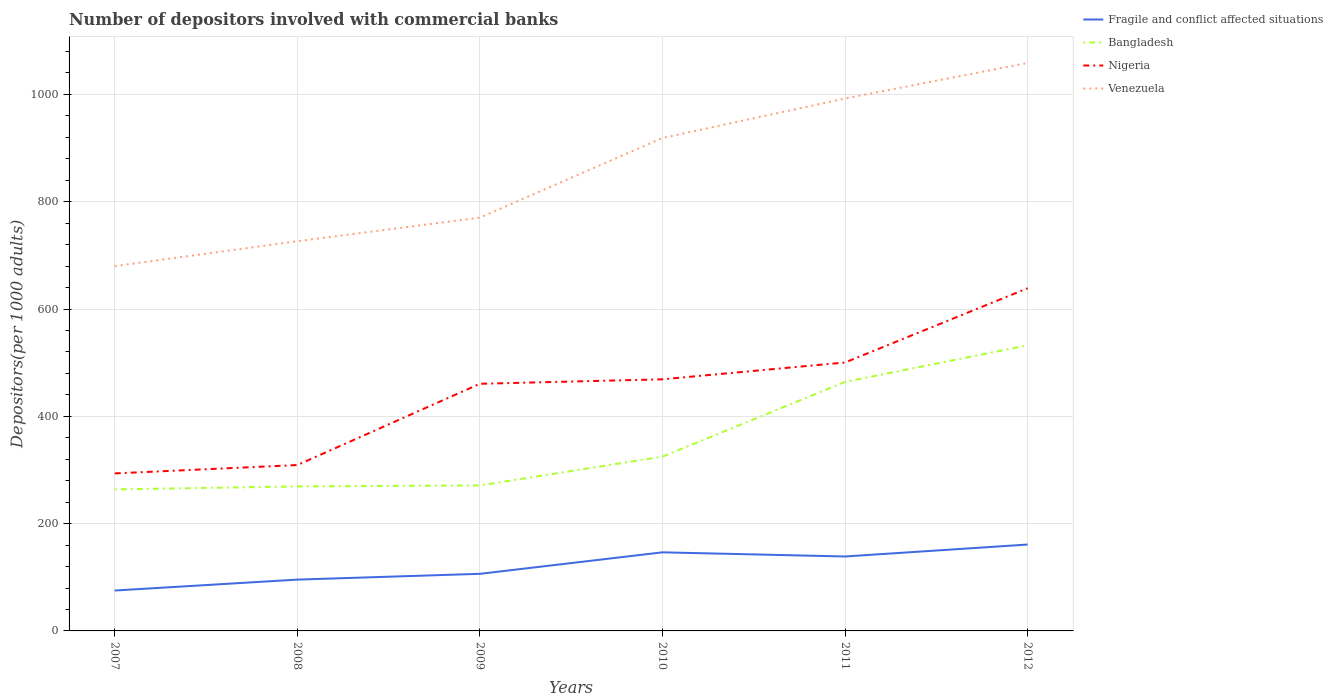Is the number of lines equal to the number of legend labels?
Offer a terse response. Yes. Across all years, what is the maximum number of depositors involved with commercial banks in Bangladesh?
Make the answer very short. 263.8. In which year was the number of depositors involved with commercial banks in Venezuela maximum?
Offer a very short reply. 2007. What is the total number of depositors involved with commercial banks in Bangladesh in the graph?
Offer a very short reply. -1.91. What is the difference between the highest and the second highest number of depositors involved with commercial banks in Bangladesh?
Provide a short and direct response. 268.6. What is the difference between the highest and the lowest number of depositors involved with commercial banks in Venezuela?
Provide a short and direct response. 3. How many lines are there?
Keep it short and to the point. 4. How many years are there in the graph?
Your answer should be compact. 6. Are the values on the major ticks of Y-axis written in scientific E-notation?
Offer a terse response. No. Does the graph contain any zero values?
Your response must be concise. No. Where does the legend appear in the graph?
Your response must be concise. Top right. How many legend labels are there?
Your answer should be very brief. 4. How are the legend labels stacked?
Your response must be concise. Vertical. What is the title of the graph?
Provide a short and direct response. Number of depositors involved with commercial banks. What is the label or title of the Y-axis?
Offer a terse response. Depositors(per 1000 adults). What is the Depositors(per 1000 adults) of Fragile and conflict affected situations in 2007?
Your answer should be very brief. 75.3. What is the Depositors(per 1000 adults) in Bangladesh in 2007?
Offer a terse response. 263.8. What is the Depositors(per 1000 adults) in Nigeria in 2007?
Ensure brevity in your answer.  293.59. What is the Depositors(per 1000 adults) of Venezuela in 2007?
Provide a succinct answer. 679.99. What is the Depositors(per 1000 adults) in Fragile and conflict affected situations in 2008?
Ensure brevity in your answer.  95.65. What is the Depositors(per 1000 adults) of Bangladesh in 2008?
Provide a short and direct response. 269.32. What is the Depositors(per 1000 adults) of Nigeria in 2008?
Offer a very short reply. 309.17. What is the Depositors(per 1000 adults) in Venezuela in 2008?
Give a very brief answer. 726.32. What is the Depositors(per 1000 adults) of Fragile and conflict affected situations in 2009?
Your answer should be very brief. 106.41. What is the Depositors(per 1000 adults) in Bangladesh in 2009?
Offer a very short reply. 271.23. What is the Depositors(per 1000 adults) of Nigeria in 2009?
Provide a succinct answer. 460.66. What is the Depositors(per 1000 adults) in Venezuela in 2009?
Provide a succinct answer. 770.33. What is the Depositors(per 1000 adults) in Fragile and conflict affected situations in 2010?
Keep it short and to the point. 146.5. What is the Depositors(per 1000 adults) of Bangladesh in 2010?
Ensure brevity in your answer.  324.78. What is the Depositors(per 1000 adults) in Nigeria in 2010?
Your answer should be compact. 468.98. What is the Depositors(per 1000 adults) of Venezuela in 2010?
Give a very brief answer. 918.79. What is the Depositors(per 1000 adults) in Fragile and conflict affected situations in 2011?
Keep it short and to the point. 138.74. What is the Depositors(per 1000 adults) in Bangladesh in 2011?
Keep it short and to the point. 464.13. What is the Depositors(per 1000 adults) in Nigeria in 2011?
Make the answer very short. 500.36. What is the Depositors(per 1000 adults) in Venezuela in 2011?
Offer a terse response. 992.39. What is the Depositors(per 1000 adults) of Fragile and conflict affected situations in 2012?
Ensure brevity in your answer.  161.02. What is the Depositors(per 1000 adults) in Bangladesh in 2012?
Provide a succinct answer. 532.4. What is the Depositors(per 1000 adults) in Nigeria in 2012?
Your answer should be very brief. 638.71. What is the Depositors(per 1000 adults) of Venezuela in 2012?
Your response must be concise. 1058.65. Across all years, what is the maximum Depositors(per 1000 adults) in Fragile and conflict affected situations?
Offer a terse response. 161.02. Across all years, what is the maximum Depositors(per 1000 adults) in Bangladesh?
Provide a short and direct response. 532.4. Across all years, what is the maximum Depositors(per 1000 adults) of Nigeria?
Your response must be concise. 638.71. Across all years, what is the maximum Depositors(per 1000 adults) in Venezuela?
Make the answer very short. 1058.65. Across all years, what is the minimum Depositors(per 1000 adults) in Fragile and conflict affected situations?
Offer a terse response. 75.3. Across all years, what is the minimum Depositors(per 1000 adults) in Bangladesh?
Offer a terse response. 263.8. Across all years, what is the minimum Depositors(per 1000 adults) of Nigeria?
Offer a very short reply. 293.59. Across all years, what is the minimum Depositors(per 1000 adults) in Venezuela?
Offer a terse response. 679.99. What is the total Depositors(per 1000 adults) in Fragile and conflict affected situations in the graph?
Give a very brief answer. 723.62. What is the total Depositors(per 1000 adults) in Bangladesh in the graph?
Provide a succinct answer. 2125.65. What is the total Depositors(per 1000 adults) of Nigeria in the graph?
Make the answer very short. 2671.47. What is the total Depositors(per 1000 adults) in Venezuela in the graph?
Your answer should be very brief. 5146.47. What is the difference between the Depositors(per 1000 adults) of Fragile and conflict affected situations in 2007 and that in 2008?
Make the answer very short. -20.35. What is the difference between the Depositors(per 1000 adults) in Bangladesh in 2007 and that in 2008?
Offer a terse response. -5.52. What is the difference between the Depositors(per 1000 adults) in Nigeria in 2007 and that in 2008?
Provide a short and direct response. -15.58. What is the difference between the Depositors(per 1000 adults) in Venezuela in 2007 and that in 2008?
Provide a succinct answer. -46.33. What is the difference between the Depositors(per 1000 adults) in Fragile and conflict affected situations in 2007 and that in 2009?
Offer a very short reply. -31.11. What is the difference between the Depositors(per 1000 adults) in Bangladesh in 2007 and that in 2009?
Offer a terse response. -7.43. What is the difference between the Depositors(per 1000 adults) in Nigeria in 2007 and that in 2009?
Provide a short and direct response. -167.06. What is the difference between the Depositors(per 1000 adults) of Venezuela in 2007 and that in 2009?
Provide a succinct answer. -90.34. What is the difference between the Depositors(per 1000 adults) of Fragile and conflict affected situations in 2007 and that in 2010?
Your answer should be very brief. -71.2. What is the difference between the Depositors(per 1000 adults) in Bangladesh in 2007 and that in 2010?
Keep it short and to the point. -60.98. What is the difference between the Depositors(per 1000 adults) of Nigeria in 2007 and that in 2010?
Your answer should be very brief. -175.39. What is the difference between the Depositors(per 1000 adults) of Venezuela in 2007 and that in 2010?
Your answer should be very brief. -238.8. What is the difference between the Depositors(per 1000 adults) in Fragile and conflict affected situations in 2007 and that in 2011?
Offer a very short reply. -63.44. What is the difference between the Depositors(per 1000 adults) of Bangladesh in 2007 and that in 2011?
Provide a short and direct response. -200.33. What is the difference between the Depositors(per 1000 adults) in Nigeria in 2007 and that in 2011?
Give a very brief answer. -206.77. What is the difference between the Depositors(per 1000 adults) in Venezuela in 2007 and that in 2011?
Provide a succinct answer. -312.4. What is the difference between the Depositors(per 1000 adults) of Fragile and conflict affected situations in 2007 and that in 2012?
Give a very brief answer. -85.72. What is the difference between the Depositors(per 1000 adults) in Bangladesh in 2007 and that in 2012?
Your answer should be very brief. -268.6. What is the difference between the Depositors(per 1000 adults) in Nigeria in 2007 and that in 2012?
Your answer should be very brief. -345.12. What is the difference between the Depositors(per 1000 adults) of Venezuela in 2007 and that in 2012?
Your answer should be compact. -378.66. What is the difference between the Depositors(per 1000 adults) in Fragile and conflict affected situations in 2008 and that in 2009?
Provide a succinct answer. -10.75. What is the difference between the Depositors(per 1000 adults) in Bangladesh in 2008 and that in 2009?
Your answer should be compact. -1.91. What is the difference between the Depositors(per 1000 adults) in Nigeria in 2008 and that in 2009?
Make the answer very short. -151.48. What is the difference between the Depositors(per 1000 adults) of Venezuela in 2008 and that in 2009?
Keep it short and to the point. -44.02. What is the difference between the Depositors(per 1000 adults) in Fragile and conflict affected situations in 2008 and that in 2010?
Give a very brief answer. -50.84. What is the difference between the Depositors(per 1000 adults) in Bangladesh in 2008 and that in 2010?
Provide a succinct answer. -55.46. What is the difference between the Depositors(per 1000 adults) in Nigeria in 2008 and that in 2010?
Offer a terse response. -159.8. What is the difference between the Depositors(per 1000 adults) in Venezuela in 2008 and that in 2010?
Provide a short and direct response. -192.47. What is the difference between the Depositors(per 1000 adults) of Fragile and conflict affected situations in 2008 and that in 2011?
Keep it short and to the point. -43.09. What is the difference between the Depositors(per 1000 adults) of Bangladesh in 2008 and that in 2011?
Your response must be concise. -194.81. What is the difference between the Depositors(per 1000 adults) of Nigeria in 2008 and that in 2011?
Ensure brevity in your answer.  -191.18. What is the difference between the Depositors(per 1000 adults) of Venezuela in 2008 and that in 2011?
Give a very brief answer. -266.07. What is the difference between the Depositors(per 1000 adults) in Fragile and conflict affected situations in 2008 and that in 2012?
Provide a short and direct response. -65.37. What is the difference between the Depositors(per 1000 adults) of Bangladesh in 2008 and that in 2012?
Ensure brevity in your answer.  -263.08. What is the difference between the Depositors(per 1000 adults) of Nigeria in 2008 and that in 2012?
Your response must be concise. -329.54. What is the difference between the Depositors(per 1000 adults) of Venezuela in 2008 and that in 2012?
Offer a terse response. -332.33. What is the difference between the Depositors(per 1000 adults) of Fragile and conflict affected situations in 2009 and that in 2010?
Your response must be concise. -40.09. What is the difference between the Depositors(per 1000 adults) of Bangladesh in 2009 and that in 2010?
Your answer should be compact. -53.55. What is the difference between the Depositors(per 1000 adults) of Nigeria in 2009 and that in 2010?
Make the answer very short. -8.32. What is the difference between the Depositors(per 1000 adults) of Venezuela in 2009 and that in 2010?
Offer a very short reply. -148.45. What is the difference between the Depositors(per 1000 adults) in Fragile and conflict affected situations in 2009 and that in 2011?
Ensure brevity in your answer.  -32.34. What is the difference between the Depositors(per 1000 adults) in Bangladesh in 2009 and that in 2011?
Provide a short and direct response. -192.9. What is the difference between the Depositors(per 1000 adults) of Nigeria in 2009 and that in 2011?
Your answer should be compact. -39.7. What is the difference between the Depositors(per 1000 adults) of Venezuela in 2009 and that in 2011?
Keep it short and to the point. -222.05. What is the difference between the Depositors(per 1000 adults) in Fragile and conflict affected situations in 2009 and that in 2012?
Your answer should be compact. -54.61. What is the difference between the Depositors(per 1000 adults) of Bangladesh in 2009 and that in 2012?
Your answer should be very brief. -261.17. What is the difference between the Depositors(per 1000 adults) of Nigeria in 2009 and that in 2012?
Provide a succinct answer. -178.06. What is the difference between the Depositors(per 1000 adults) of Venezuela in 2009 and that in 2012?
Your answer should be compact. -288.32. What is the difference between the Depositors(per 1000 adults) of Fragile and conflict affected situations in 2010 and that in 2011?
Provide a short and direct response. 7.75. What is the difference between the Depositors(per 1000 adults) of Bangladesh in 2010 and that in 2011?
Your answer should be very brief. -139.35. What is the difference between the Depositors(per 1000 adults) in Nigeria in 2010 and that in 2011?
Your response must be concise. -31.38. What is the difference between the Depositors(per 1000 adults) of Venezuela in 2010 and that in 2011?
Make the answer very short. -73.6. What is the difference between the Depositors(per 1000 adults) in Fragile and conflict affected situations in 2010 and that in 2012?
Provide a short and direct response. -14.52. What is the difference between the Depositors(per 1000 adults) of Bangladesh in 2010 and that in 2012?
Give a very brief answer. -207.62. What is the difference between the Depositors(per 1000 adults) in Nigeria in 2010 and that in 2012?
Make the answer very short. -169.73. What is the difference between the Depositors(per 1000 adults) in Venezuela in 2010 and that in 2012?
Your response must be concise. -139.86. What is the difference between the Depositors(per 1000 adults) of Fragile and conflict affected situations in 2011 and that in 2012?
Your response must be concise. -22.28. What is the difference between the Depositors(per 1000 adults) in Bangladesh in 2011 and that in 2012?
Keep it short and to the point. -68.27. What is the difference between the Depositors(per 1000 adults) in Nigeria in 2011 and that in 2012?
Your response must be concise. -138.36. What is the difference between the Depositors(per 1000 adults) of Venezuela in 2011 and that in 2012?
Your response must be concise. -66.26. What is the difference between the Depositors(per 1000 adults) in Fragile and conflict affected situations in 2007 and the Depositors(per 1000 adults) in Bangladesh in 2008?
Ensure brevity in your answer.  -194.02. What is the difference between the Depositors(per 1000 adults) in Fragile and conflict affected situations in 2007 and the Depositors(per 1000 adults) in Nigeria in 2008?
Keep it short and to the point. -233.88. What is the difference between the Depositors(per 1000 adults) in Fragile and conflict affected situations in 2007 and the Depositors(per 1000 adults) in Venezuela in 2008?
Your answer should be very brief. -651.02. What is the difference between the Depositors(per 1000 adults) of Bangladesh in 2007 and the Depositors(per 1000 adults) of Nigeria in 2008?
Give a very brief answer. -45.38. What is the difference between the Depositors(per 1000 adults) of Bangladesh in 2007 and the Depositors(per 1000 adults) of Venezuela in 2008?
Keep it short and to the point. -462.52. What is the difference between the Depositors(per 1000 adults) in Nigeria in 2007 and the Depositors(per 1000 adults) in Venezuela in 2008?
Your answer should be very brief. -432.73. What is the difference between the Depositors(per 1000 adults) of Fragile and conflict affected situations in 2007 and the Depositors(per 1000 adults) of Bangladesh in 2009?
Make the answer very short. -195.93. What is the difference between the Depositors(per 1000 adults) in Fragile and conflict affected situations in 2007 and the Depositors(per 1000 adults) in Nigeria in 2009?
Give a very brief answer. -385.36. What is the difference between the Depositors(per 1000 adults) in Fragile and conflict affected situations in 2007 and the Depositors(per 1000 adults) in Venezuela in 2009?
Offer a terse response. -695.04. What is the difference between the Depositors(per 1000 adults) of Bangladesh in 2007 and the Depositors(per 1000 adults) of Nigeria in 2009?
Give a very brief answer. -196.86. What is the difference between the Depositors(per 1000 adults) of Bangladesh in 2007 and the Depositors(per 1000 adults) of Venezuela in 2009?
Make the answer very short. -506.54. What is the difference between the Depositors(per 1000 adults) in Nigeria in 2007 and the Depositors(per 1000 adults) in Venezuela in 2009?
Your response must be concise. -476.74. What is the difference between the Depositors(per 1000 adults) of Fragile and conflict affected situations in 2007 and the Depositors(per 1000 adults) of Bangladesh in 2010?
Give a very brief answer. -249.48. What is the difference between the Depositors(per 1000 adults) in Fragile and conflict affected situations in 2007 and the Depositors(per 1000 adults) in Nigeria in 2010?
Offer a very short reply. -393.68. What is the difference between the Depositors(per 1000 adults) of Fragile and conflict affected situations in 2007 and the Depositors(per 1000 adults) of Venezuela in 2010?
Make the answer very short. -843.49. What is the difference between the Depositors(per 1000 adults) of Bangladesh in 2007 and the Depositors(per 1000 adults) of Nigeria in 2010?
Your response must be concise. -205.18. What is the difference between the Depositors(per 1000 adults) of Bangladesh in 2007 and the Depositors(per 1000 adults) of Venezuela in 2010?
Your answer should be very brief. -654.99. What is the difference between the Depositors(per 1000 adults) in Nigeria in 2007 and the Depositors(per 1000 adults) in Venezuela in 2010?
Make the answer very short. -625.2. What is the difference between the Depositors(per 1000 adults) of Fragile and conflict affected situations in 2007 and the Depositors(per 1000 adults) of Bangladesh in 2011?
Ensure brevity in your answer.  -388.83. What is the difference between the Depositors(per 1000 adults) in Fragile and conflict affected situations in 2007 and the Depositors(per 1000 adults) in Nigeria in 2011?
Offer a very short reply. -425.06. What is the difference between the Depositors(per 1000 adults) in Fragile and conflict affected situations in 2007 and the Depositors(per 1000 adults) in Venezuela in 2011?
Offer a very short reply. -917.09. What is the difference between the Depositors(per 1000 adults) in Bangladesh in 2007 and the Depositors(per 1000 adults) in Nigeria in 2011?
Ensure brevity in your answer.  -236.56. What is the difference between the Depositors(per 1000 adults) of Bangladesh in 2007 and the Depositors(per 1000 adults) of Venezuela in 2011?
Offer a terse response. -728.59. What is the difference between the Depositors(per 1000 adults) in Nigeria in 2007 and the Depositors(per 1000 adults) in Venezuela in 2011?
Give a very brief answer. -698.8. What is the difference between the Depositors(per 1000 adults) in Fragile and conflict affected situations in 2007 and the Depositors(per 1000 adults) in Bangladesh in 2012?
Your answer should be very brief. -457.1. What is the difference between the Depositors(per 1000 adults) of Fragile and conflict affected situations in 2007 and the Depositors(per 1000 adults) of Nigeria in 2012?
Offer a very short reply. -563.41. What is the difference between the Depositors(per 1000 adults) in Fragile and conflict affected situations in 2007 and the Depositors(per 1000 adults) in Venezuela in 2012?
Offer a terse response. -983.35. What is the difference between the Depositors(per 1000 adults) of Bangladesh in 2007 and the Depositors(per 1000 adults) of Nigeria in 2012?
Your response must be concise. -374.91. What is the difference between the Depositors(per 1000 adults) of Bangladesh in 2007 and the Depositors(per 1000 adults) of Venezuela in 2012?
Ensure brevity in your answer.  -794.85. What is the difference between the Depositors(per 1000 adults) in Nigeria in 2007 and the Depositors(per 1000 adults) in Venezuela in 2012?
Offer a very short reply. -765.06. What is the difference between the Depositors(per 1000 adults) in Fragile and conflict affected situations in 2008 and the Depositors(per 1000 adults) in Bangladesh in 2009?
Your answer should be compact. -175.58. What is the difference between the Depositors(per 1000 adults) in Fragile and conflict affected situations in 2008 and the Depositors(per 1000 adults) in Nigeria in 2009?
Offer a terse response. -365. What is the difference between the Depositors(per 1000 adults) in Fragile and conflict affected situations in 2008 and the Depositors(per 1000 adults) in Venezuela in 2009?
Give a very brief answer. -674.68. What is the difference between the Depositors(per 1000 adults) of Bangladesh in 2008 and the Depositors(per 1000 adults) of Nigeria in 2009?
Provide a short and direct response. -191.34. What is the difference between the Depositors(per 1000 adults) in Bangladesh in 2008 and the Depositors(per 1000 adults) in Venezuela in 2009?
Offer a terse response. -501.02. What is the difference between the Depositors(per 1000 adults) of Nigeria in 2008 and the Depositors(per 1000 adults) of Venezuela in 2009?
Ensure brevity in your answer.  -461.16. What is the difference between the Depositors(per 1000 adults) in Fragile and conflict affected situations in 2008 and the Depositors(per 1000 adults) in Bangladesh in 2010?
Your answer should be compact. -229.12. What is the difference between the Depositors(per 1000 adults) of Fragile and conflict affected situations in 2008 and the Depositors(per 1000 adults) of Nigeria in 2010?
Your answer should be very brief. -373.33. What is the difference between the Depositors(per 1000 adults) of Fragile and conflict affected situations in 2008 and the Depositors(per 1000 adults) of Venezuela in 2010?
Keep it short and to the point. -823.14. What is the difference between the Depositors(per 1000 adults) in Bangladesh in 2008 and the Depositors(per 1000 adults) in Nigeria in 2010?
Make the answer very short. -199.66. What is the difference between the Depositors(per 1000 adults) in Bangladesh in 2008 and the Depositors(per 1000 adults) in Venezuela in 2010?
Ensure brevity in your answer.  -649.47. What is the difference between the Depositors(per 1000 adults) in Nigeria in 2008 and the Depositors(per 1000 adults) in Venezuela in 2010?
Offer a very short reply. -609.62. What is the difference between the Depositors(per 1000 adults) in Fragile and conflict affected situations in 2008 and the Depositors(per 1000 adults) in Bangladesh in 2011?
Ensure brevity in your answer.  -368.48. What is the difference between the Depositors(per 1000 adults) in Fragile and conflict affected situations in 2008 and the Depositors(per 1000 adults) in Nigeria in 2011?
Your response must be concise. -404.7. What is the difference between the Depositors(per 1000 adults) in Fragile and conflict affected situations in 2008 and the Depositors(per 1000 adults) in Venezuela in 2011?
Provide a succinct answer. -896.74. What is the difference between the Depositors(per 1000 adults) of Bangladesh in 2008 and the Depositors(per 1000 adults) of Nigeria in 2011?
Keep it short and to the point. -231.04. What is the difference between the Depositors(per 1000 adults) in Bangladesh in 2008 and the Depositors(per 1000 adults) in Venezuela in 2011?
Keep it short and to the point. -723.07. What is the difference between the Depositors(per 1000 adults) in Nigeria in 2008 and the Depositors(per 1000 adults) in Venezuela in 2011?
Provide a succinct answer. -683.21. What is the difference between the Depositors(per 1000 adults) of Fragile and conflict affected situations in 2008 and the Depositors(per 1000 adults) of Bangladesh in 2012?
Ensure brevity in your answer.  -436.75. What is the difference between the Depositors(per 1000 adults) in Fragile and conflict affected situations in 2008 and the Depositors(per 1000 adults) in Nigeria in 2012?
Provide a short and direct response. -543.06. What is the difference between the Depositors(per 1000 adults) of Fragile and conflict affected situations in 2008 and the Depositors(per 1000 adults) of Venezuela in 2012?
Keep it short and to the point. -963. What is the difference between the Depositors(per 1000 adults) of Bangladesh in 2008 and the Depositors(per 1000 adults) of Nigeria in 2012?
Give a very brief answer. -369.39. What is the difference between the Depositors(per 1000 adults) in Bangladesh in 2008 and the Depositors(per 1000 adults) in Venezuela in 2012?
Make the answer very short. -789.33. What is the difference between the Depositors(per 1000 adults) in Nigeria in 2008 and the Depositors(per 1000 adults) in Venezuela in 2012?
Your response must be concise. -749.48. What is the difference between the Depositors(per 1000 adults) of Fragile and conflict affected situations in 2009 and the Depositors(per 1000 adults) of Bangladesh in 2010?
Your answer should be compact. -218.37. What is the difference between the Depositors(per 1000 adults) in Fragile and conflict affected situations in 2009 and the Depositors(per 1000 adults) in Nigeria in 2010?
Give a very brief answer. -362.57. What is the difference between the Depositors(per 1000 adults) of Fragile and conflict affected situations in 2009 and the Depositors(per 1000 adults) of Venezuela in 2010?
Your answer should be compact. -812.38. What is the difference between the Depositors(per 1000 adults) of Bangladesh in 2009 and the Depositors(per 1000 adults) of Nigeria in 2010?
Your response must be concise. -197.75. What is the difference between the Depositors(per 1000 adults) of Bangladesh in 2009 and the Depositors(per 1000 adults) of Venezuela in 2010?
Your answer should be compact. -647.56. What is the difference between the Depositors(per 1000 adults) in Nigeria in 2009 and the Depositors(per 1000 adults) in Venezuela in 2010?
Your answer should be compact. -458.13. What is the difference between the Depositors(per 1000 adults) in Fragile and conflict affected situations in 2009 and the Depositors(per 1000 adults) in Bangladesh in 2011?
Provide a succinct answer. -357.72. What is the difference between the Depositors(per 1000 adults) in Fragile and conflict affected situations in 2009 and the Depositors(per 1000 adults) in Nigeria in 2011?
Your answer should be very brief. -393.95. What is the difference between the Depositors(per 1000 adults) in Fragile and conflict affected situations in 2009 and the Depositors(per 1000 adults) in Venezuela in 2011?
Provide a short and direct response. -885.98. What is the difference between the Depositors(per 1000 adults) in Bangladesh in 2009 and the Depositors(per 1000 adults) in Nigeria in 2011?
Offer a very short reply. -229.13. What is the difference between the Depositors(per 1000 adults) of Bangladesh in 2009 and the Depositors(per 1000 adults) of Venezuela in 2011?
Ensure brevity in your answer.  -721.16. What is the difference between the Depositors(per 1000 adults) of Nigeria in 2009 and the Depositors(per 1000 adults) of Venezuela in 2011?
Provide a short and direct response. -531.73. What is the difference between the Depositors(per 1000 adults) of Fragile and conflict affected situations in 2009 and the Depositors(per 1000 adults) of Bangladesh in 2012?
Make the answer very short. -425.99. What is the difference between the Depositors(per 1000 adults) in Fragile and conflict affected situations in 2009 and the Depositors(per 1000 adults) in Nigeria in 2012?
Offer a very short reply. -532.3. What is the difference between the Depositors(per 1000 adults) of Fragile and conflict affected situations in 2009 and the Depositors(per 1000 adults) of Venezuela in 2012?
Offer a very short reply. -952.25. What is the difference between the Depositors(per 1000 adults) of Bangladesh in 2009 and the Depositors(per 1000 adults) of Nigeria in 2012?
Make the answer very short. -367.48. What is the difference between the Depositors(per 1000 adults) in Bangladesh in 2009 and the Depositors(per 1000 adults) in Venezuela in 2012?
Offer a terse response. -787.42. What is the difference between the Depositors(per 1000 adults) in Nigeria in 2009 and the Depositors(per 1000 adults) in Venezuela in 2012?
Your response must be concise. -598. What is the difference between the Depositors(per 1000 adults) in Fragile and conflict affected situations in 2010 and the Depositors(per 1000 adults) in Bangladesh in 2011?
Your answer should be very brief. -317.63. What is the difference between the Depositors(per 1000 adults) in Fragile and conflict affected situations in 2010 and the Depositors(per 1000 adults) in Nigeria in 2011?
Offer a terse response. -353.86. What is the difference between the Depositors(per 1000 adults) of Fragile and conflict affected situations in 2010 and the Depositors(per 1000 adults) of Venezuela in 2011?
Your answer should be compact. -845.89. What is the difference between the Depositors(per 1000 adults) of Bangladesh in 2010 and the Depositors(per 1000 adults) of Nigeria in 2011?
Ensure brevity in your answer.  -175.58. What is the difference between the Depositors(per 1000 adults) of Bangladesh in 2010 and the Depositors(per 1000 adults) of Venezuela in 2011?
Offer a very short reply. -667.61. What is the difference between the Depositors(per 1000 adults) of Nigeria in 2010 and the Depositors(per 1000 adults) of Venezuela in 2011?
Ensure brevity in your answer.  -523.41. What is the difference between the Depositors(per 1000 adults) of Fragile and conflict affected situations in 2010 and the Depositors(per 1000 adults) of Bangladesh in 2012?
Offer a terse response. -385.9. What is the difference between the Depositors(per 1000 adults) of Fragile and conflict affected situations in 2010 and the Depositors(per 1000 adults) of Nigeria in 2012?
Keep it short and to the point. -492.22. What is the difference between the Depositors(per 1000 adults) of Fragile and conflict affected situations in 2010 and the Depositors(per 1000 adults) of Venezuela in 2012?
Make the answer very short. -912.16. What is the difference between the Depositors(per 1000 adults) of Bangladesh in 2010 and the Depositors(per 1000 adults) of Nigeria in 2012?
Give a very brief answer. -313.94. What is the difference between the Depositors(per 1000 adults) of Bangladesh in 2010 and the Depositors(per 1000 adults) of Venezuela in 2012?
Provide a succinct answer. -733.88. What is the difference between the Depositors(per 1000 adults) of Nigeria in 2010 and the Depositors(per 1000 adults) of Venezuela in 2012?
Your response must be concise. -589.67. What is the difference between the Depositors(per 1000 adults) in Fragile and conflict affected situations in 2011 and the Depositors(per 1000 adults) in Bangladesh in 2012?
Your answer should be very brief. -393.65. What is the difference between the Depositors(per 1000 adults) of Fragile and conflict affected situations in 2011 and the Depositors(per 1000 adults) of Nigeria in 2012?
Ensure brevity in your answer.  -499.97. What is the difference between the Depositors(per 1000 adults) of Fragile and conflict affected situations in 2011 and the Depositors(per 1000 adults) of Venezuela in 2012?
Make the answer very short. -919.91. What is the difference between the Depositors(per 1000 adults) of Bangladesh in 2011 and the Depositors(per 1000 adults) of Nigeria in 2012?
Give a very brief answer. -174.58. What is the difference between the Depositors(per 1000 adults) in Bangladesh in 2011 and the Depositors(per 1000 adults) in Venezuela in 2012?
Offer a terse response. -594.52. What is the difference between the Depositors(per 1000 adults) in Nigeria in 2011 and the Depositors(per 1000 adults) in Venezuela in 2012?
Your response must be concise. -558.3. What is the average Depositors(per 1000 adults) in Fragile and conflict affected situations per year?
Your response must be concise. 120.6. What is the average Depositors(per 1000 adults) in Bangladesh per year?
Your response must be concise. 354.27. What is the average Depositors(per 1000 adults) in Nigeria per year?
Keep it short and to the point. 445.24. What is the average Depositors(per 1000 adults) of Venezuela per year?
Ensure brevity in your answer.  857.75. In the year 2007, what is the difference between the Depositors(per 1000 adults) of Fragile and conflict affected situations and Depositors(per 1000 adults) of Bangladesh?
Your response must be concise. -188.5. In the year 2007, what is the difference between the Depositors(per 1000 adults) of Fragile and conflict affected situations and Depositors(per 1000 adults) of Nigeria?
Keep it short and to the point. -218.29. In the year 2007, what is the difference between the Depositors(per 1000 adults) of Fragile and conflict affected situations and Depositors(per 1000 adults) of Venezuela?
Offer a very short reply. -604.69. In the year 2007, what is the difference between the Depositors(per 1000 adults) in Bangladesh and Depositors(per 1000 adults) in Nigeria?
Offer a terse response. -29.79. In the year 2007, what is the difference between the Depositors(per 1000 adults) of Bangladesh and Depositors(per 1000 adults) of Venezuela?
Make the answer very short. -416.19. In the year 2007, what is the difference between the Depositors(per 1000 adults) of Nigeria and Depositors(per 1000 adults) of Venezuela?
Make the answer very short. -386.4. In the year 2008, what is the difference between the Depositors(per 1000 adults) of Fragile and conflict affected situations and Depositors(per 1000 adults) of Bangladesh?
Offer a very short reply. -173.67. In the year 2008, what is the difference between the Depositors(per 1000 adults) of Fragile and conflict affected situations and Depositors(per 1000 adults) of Nigeria?
Give a very brief answer. -213.52. In the year 2008, what is the difference between the Depositors(per 1000 adults) in Fragile and conflict affected situations and Depositors(per 1000 adults) in Venezuela?
Your answer should be very brief. -630.67. In the year 2008, what is the difference between the Depositors(per 1000 adults) of Bangladesh and Depositors(per 1000 adults) of Nigeria?
Ensure brevity in your answer.  -39.85. In the year 2008, what is the difference between the Depositors(per 1000 adults) of Bangladesh and Depositors(per 1000 adults) of Venezuela?
Your answer should be compact. -457. In the year 2008, what is the difference between the Depositors(per 1000 adults) of Nigeria and Depositors(per 1000 adults) of Venezuela?
Offer a very short reply. -417.15. In the year 2009, what is the difference between the Depositors(per 1000 adults) of Fragile and conflict affected situations and Depositors(per 1000 adults) of Bangladesh?
Your answer should be compact. -164.82. In the year 2009, what is the difference between the Depositors(per 1000 adults) of Fragile and conflict affected situations and Depositors(per 1000 adults) of Nigeria?
Keep it short and to the point. -354.25. In the year 2009, what is the difference between the Depositors(per 1000 adults) of Fragile and conflict affected situations and Depositors(per 1000 adults) of Venezuela?
Give a very brief answer. -663.93. In the year 2009, what is the difference between the Depositors(per 1000 adults) of Bangladesh and Depositors(per 1000 adults) of Nigeria?
Provide a short and direct response. -189.43. In the year 2009, what is the difference between the Depositors(per 1000 adults) in Bangladesh and Depositors(per 1000 adults) in Venezuela?
Give a very brief answer. -499.11. In the year 2009, what is the difference between the Depositors(per 1000 adults) of Nigeria and Depositors(per 1000 adults) of Venezuela?
Provide a short and direct response. -309.68. In the year 2010, what is the difference between the Depositors(per 1000 adults) in Fragile and conflict affected situations and Depositors(per 1000 adults) in Bangladesh?
Provide a succinct answer. -178.28. In the year 2010, what is the difference between the Depositors(per 1000 adults) of Fragile and conflict affected situations and Depositors(per 1000 adults) of Nigeria?
Make the answer very short. -322.48. In the year 2010, what is the difference between the Depositors(per 1000 adults) in Fragile and conflict affected situations and Depositors(per 1000 adults) in Venezuela?
Ensure brevity in your answer.  -772.29. In the year 2010, what is the difference between the Depositors(per 1000 adults) in Bangladesh and Depositors(per 1000 adults) in Nigeria?
Make the answer very short. -144.2. In the year 2010, what is the difference between the Depositors(per 1000 adults) of Bangladesh and Depositors(per 1000 adults) of Venezuela?
Your answer should be compact. -594.01. In the year 2010, what is the difference between the Depositors(per 1000 adults) of Nigeria and Depositors(per 1000 adults) of Venezuela?
Keep it short and to the point. -449.81. In the year 2011, what is the difference between the Depositors(per 1000 adults) of Fragile and conflict affected situations and Depositors(per 1000 adults) of Bangladesh?
Offer a terse response. -325.39. In the year 2011, what is the difference between the Depositors(per 1000 adults) in Fragile and conflict affected situations and Depositors(per 1000 adults) in Nigeria?
Your answer should be compact. -361.61. In the year 2011, what is the difference between the Depositors(per 1000 adults) of Fragile and conflict affected situations and Depositors(per 1000 adults) of Venezuela?
Keep it short and to the point. -853.65. In the year 2011, what is the difference between the Depositors(per 1000 adults) of Bangladesh and Depositors(per 1000 adults) of Nigeria?
Give a very brief answer. -36.23. In the year 2011, what is the difference between the Depositors(per 1000 adults) in Bangladesh and Depositors(per 1000 adults) in Venezuela?
Provide a succinct answer. -528.26. In the year 2011, what is the difference between the Depositors(per 1000 adults) in Nigeria and Depositors(per 1000 adults) in Venezuela?
Provide a short and direct response. -492.03. In the year 2012, what is the difference between the Depositors(per 1000 adults) in Fragile and conflict affected situations and Depositors(per 1000 adults) in Bangladesh?
Offer a terse response. -371.38. In the year 2012, what is the difference between the Depositors(per 1000 adults) of Fragile and conflict affected situations and Depositors(per 1000 adults) of Nigeria?
Keep it short and to the point. -477.69. In the year 2012, what is the difference between the Depositors(per 1000 adults) in Fragile and conflict affected situations and Depositors(per 1000 adults) in Venezuela?
Make the answer very short. -897.63. In the year 2012, what is the difference between the Depositors(per 1000 adults) of Bangladesh and Depositors(per 1000 adults) of Nigeria?
Your answer should be very brief. -106.31. In the year 2012, what is the difference between the Depositors(per 1000 adults) of Bangladesh and Depositors(per 1000 adults) of Venezuela?
Give a very brief answer. -526.25. In the year 2012, what is the difference between the Depositors(per 1000 adults) of Nigeria and Depositors(per 1000 adults) of Venezuela?
Provide a succinct answer. -419.94. What is the ratio of the Depositors(per 1000 adults) of Fragile and conflict affected situations in 2007 to that in 2008?
Provide a succinct answer. 0.79. What is the ratio of the Depositors(per 1000 adults) of Bangladesh in 2007 to that in 2008?
Provide a succinct answer. 0.98. What is the ratio of the Depositors(per 1000 adults) in Nigeria in 2007 to that in 2008?
Provide a succinct answer. 0.95. What is the ratio of the Depositors(per 1000 adults) in Venezuela in 2007 to that in 2008?
Keep it short and to the point. 0.94. What is the ratio of the Depositors(per 1000 adults) in Fragile and conflict affected situations in 2007 to that in 2009?
Give a very brief answer. 0.71. What is the ratio of the Depositors(per 1000 adults) of Bangladesh in 2007 to that in 2009?
Provide a short and direct response. 0.97. What is the ratio of the Depositors(per 1000 adults) of Nigeria in 2007 to that in 2009?
Ensure brevity in your answer.  0.64. What is the ratio of the Depositors(per 1000 adults) of Venezuela in 2007 to that in 2009?
Your answer should be very brief. 0.88. What is the ratio of the Depositors(per 1000 adults) of Fragile and conflict affected situations in 2007 to that in 2010?
Your answer should be compact. 0.51. What is the ratio of the Depositors(per 1000 adults) of Bangladesh in 2007 to that in 2010?
Provide a succinct answer. 0.81. What is the ratio of the Depositors(per 1000 adults) of Nigeria in 2007 to that in 2010?
Keep it short and to the point. 0.63. What is the ratio of the Depositors(per 1000 adults) of Venezuela in 2007 to that in 2010?
Your answer should be very brief. 0.74. What is the ratio of the Depositors(per 1000 adults) in Fragile and conflict affected situations in 2007 to that in 2011?
Your answer should be compact. 0.54. What is the ratio of the Depositors(per 1000 adults) in Bangladesh in 2007 to that in 2011?
Offer a very short reply. 0.57. What is the ratio of the Depositors(per 1000 adults) in Nigeria in 2007 to that in 2011?
Give a very brief answer. 0.59. What is the ratio of the Depositors(per 1000 adults) of Venezuela in 2007 to that in 2011?
Your response must be concise. 0.69. What is the ratio of the Depositors(per 1000 adults) in Fragile and conflict affected situations in 2007 to that in 2012?
Make the answer very short. 0.47. What is the ratio of the Depositors(per 1000 adults) in Bangladesh in 2007 to that in 2012?
Offer a very short reply. 0.5. What is the ratio of the Depositors(per 1000 adults) in Nigeria in 2007 to that in 2012?
Your answer should be compact. 0.46. What is the ratio of the Depositors(per 1000 adults) in Venezuela in 2007 to that in 2012?
Make the answer very short. 0.64. What is the ratio of the Depositors(per 1000 adults) of Fragile and conflict affected situations in 2008 to that in 2009?
Your answer should be very brief. 0.9. What is the ratio of the Depositors(per 1000 adults) of Bangladesh in 2008 to that in 2009?
Give a very brief answer. 0.99. What is the ratio of the Depositors(per 1000 adults) in Nigeria in 2008 to that in 2009?
Give a very brief answer. 0.67. What is the ratio of the Depositors(per 1000 adults) in Venezuela in 2008 to that in 2009?
Your answer should be compact. 0.94. What is the ratio of the Depositors(per 1000 adults) of Fragile and conflict affected situations in 2008 to that in 2010?
Your answer should be very brief. 0.65. What is the ratio of the Depositors(per 1000 adults) in Bangladesh in 2008 to that in 2010?
Your answer should be very brief. 0.83. What is the ratio of the Depositors(per 1000 adults) in Nigeria in 2008 to that in 2010?
Offer a terse response. 0.66. What is the ratio of the Depositors(per 1000 adults) in Venezuela in 2008 to that in 2010?
Offer a very short reply. 0.79. What is the ratio of the Depositors(per 1000 adults) of Fragile and conflict affected situations in 2008 to that in 2011?
Provide a short and direct response. 0.69. What is the ratio of the Depositors(per 1000 adults) of Bangladesh in 2008 to that in 2011?
Keep it short and to the point. 0.58. What is the ratio of the Depositors(per 1000 adults) of Nigeria in 2008 to that in 2011?
Your response must be concise. 0.62. What is the ratio of the Depositors(per 1000 adults) of Venezuela in 2008 to that in 2011?
Provide a succinct answer. 0.73. What is the ratio of the Depositors(per 1000 adults) in Fragile and conflict affected situations in 2008 to that in 2012?
Give a very brief answer. 0.59. What is the ratio of the Depositors(per 1000 adults) in Bangladesh in 2008 to that in 2012?
Your answer should be very brief. 0.51. What is the ratio of the Depositors(per 1000 adults) of Nigeria in 2008 to that in 2012?
Make the answer very short. 0.48. What is the ratio of the Depositors(per 1000 adults) in Venezuela in 2008 to that in 2012?
Keep it short and to the point. 0.69. What is the ratio of the Depositors(per 1000 adults) of Fragile and conflict affected situations in 2009 to that in 2010?
Give a very brief answer. 0.73. What is the ratio of the Depositors(per 1000 adults) in Bangladesh in 2009 to that in 2010?
Keep it short and to the point. 0.84. What is the ratio of the Depositors(per 1000 adults) of Nigeria in 2009 to that in 2010?
Offer a terse response. 0.98. What is the ratio of the Depositors(per 1000 adults) in Venezuela in 2009 to that in 2010?
Provide a succinct answer. 0.84. What is the ratio of the Depositors(per 1000 adults) of Fragile and conflict affected situations in 2009 to that in 2011?
Make the answer very short. 0.77. What is the ratio of the Depositors(per 1000 adults) in Bangladesh in 2009 to that in 2011?
Your answer should be very brief. 0.58. What is the ratio of the Depositors(per 1000 adults) of Nigeria in 2009 to that in 2011?
Offer a very short reply. 0.92. What is the ratio of the Depositors(per 1000 adults) of Venezuela in 2009 to that in 2011?
Your answer should be very brief. 0.78. What is the ratio of the Depositors(per 1000 adults) of Fragile and conflict affected situations in 2009 to that in 2012?
Offer a terse response. 0.66. What is the ratio of the Depositors(per 1000 adults) in Bangladesh in 2009 to that in 2012?
Keep it short and to the point. 0.51. What is the ratio of the Depositors(per 1000 adults) in Nigeria in 2009 to that in 2012?
Provide a short and direct response. 0.72. What is the ratio of the Depositors(per 1000 adults) of Venezuela in 2009 to that in 2012?
Ensure brevity in your answer.  0.73. What is the ratio of the Depositors(per 1000 adults) in Fragile and conflict affected situations in 2010 to that in 2011?
Your response must be concise. 1.06. What is the ratio of the Depositors(per 1000 adults) in Bangladesh in 2010 to that in 2011?
Provide a succinct answer. 0.7. What is the ratio of the Depositors(per 1000 adults) in Nigeria in 2010 to that in 2011?
Your answer should be compact. 0.94. What is the ratio of the Depositors(per 1000 adults) of Venezuela in 2010 to that in 2011?
Make the answer very short. 0.93. What is the ratio of the Depositors(per 1000 adults) in Fragile and conflict affected situations in 2010 to that in 2012?
Ensure brevity in your answer.  0.91. What is the ratio of the Depositors(per 1000 adults) of Bangladesh in 2010 to that in 2012?
Offer a terse response. 0.61. What is the ratio of the Depositors(per 1000 adults) of Nigeria in 2010 to that in 2012?
Ensure brevity in your answer.  0.73. What is the ratio of the Depositors(per 1000 adults) of Venezuela in 2010 to that in 2012?
Your answer should be compact. 0.87. What is the ratio of the Depositors(per 1000 adults) of Fragile and conflict affected situations in 2011 to that in 2012?
Keep it short and to the point. 0.86. What is the ratio of the Depositors(per 1000 adults) of Bangladesh in 2011 to that in 2012?
Keep it short and to the point. 0.87. What is the ratio of the Depositors(per 1000 adults) in Nigeria in 2011 to that in 2012?
Provide a short and direct response. 0.78. What is the ratio of the Depositors(per 1000 adults) in Venezuela in 2011 to that in 2012?
Offer a very short reply. 0.94. What is the difference between the highest and the second highest Depositors(per 1000 adults) in Fragile and conflict affected situations?
Your answer should be compact. 14.52. What is the difference between the highest and the second highest Depositors(per 1000 adults) in Bangladesh?
Make the answer very short. 68.27. What is the difference between the highest and the second highest Depositors(per 1000 adults) of Nigeria?
Your answer should be compact. 138.36. What is the difference between the highest and the second highest Depositors(per 1000 adults) in Venezuela?
Give a very brief answer. 66.26. What is the difference between the highest and the lowest Depositors(per 1000 adults) in Fragile and conflict affected situations?
Your response must be concise. 85.72. What is the difference between the highest and the lowest Depositors(per 1000 adults) in Bangladesh?
Provide a short and direct response. 268.6. What is the difference between the highest and the lowest Depositors(per 1000 adults) in Nigeria?
Give a very brief answer. 345.12. What is the difference between the highest and the lowest Depositors(per 1000 adults) in Venezuela?
Offer a very short reply. 378.66. 